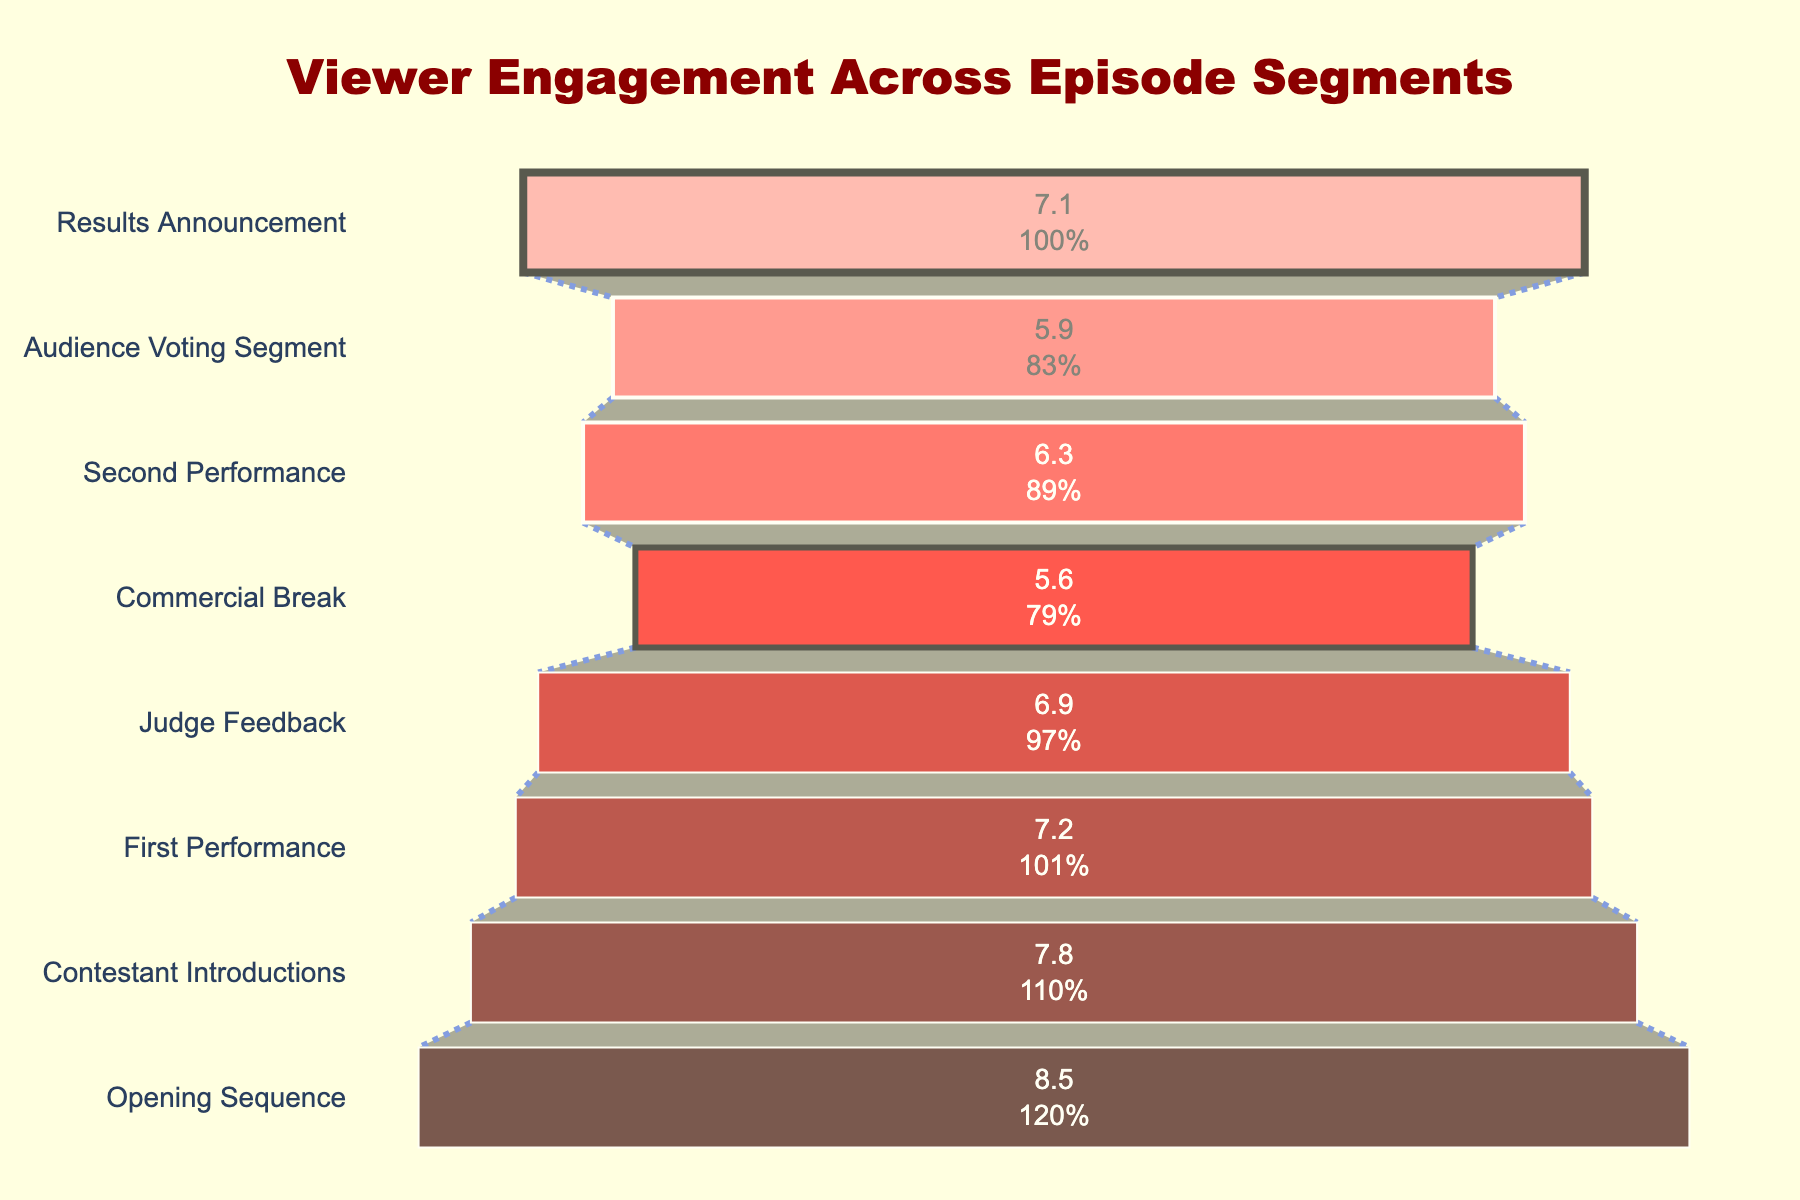What's the title of the figure? The title is displayed at the top center of the figure.
Answer: Viewer Engagement Across Episode Segments How many stages are represented in the funnel chart? We count the number of distinct segments (stages) shown along the funnel chart.
Answer: 8 What segment has the lowest viewer count? By examining the height of the bands or reading the text inside the bands, we identify the segment with the lowest value.
Answer: Commercial Break What is the total number of viewers from the Opening Sequence to the First Performance? We sum the viewers for the Opening Sequence, Contestant Introductions, and First Performance: 8.5 + 7.8 + 7.2 million viewers.
Answer: 23.5 million What percentage of the total initial viewership is retained by the Results Announcement segment? We compare the Results Announcement (7.1 million viewers) to the Opening Sequence (8.5 million viewers), calculating (7.1 / 8.5) * 100 to find the percentage retained.
Answer: 83.5% Which stage loses the most viewers compared to the previous stage? By calculating the difference between successive stages, we determine which has the largest decrease. The largest drop is from Judge Feedback (6.9) to Commercial Break (5.6).
Answer: Judge Feedback to Commercial Break How many fewer viewers were there during the Audience Voting Segment compared to the Opening Sequence? Subtract the viewers of the Audience Voting Segment (5.9 million) from the Opening Sequence (8.5 million). 8.5 - 5.9 = 2.6 million fewer viewers.
Answer: 2.6 million At which stage does the viewership increase compared to the immediately preceding stage? We look at the change in values between each consecutive stage and note where there is an increase. The viewership increases from Commercial Break (5.6 million) to Second Performance (6.3 million) and from Audience Voting Segment (5.9 million) to Results Announcement (7.1 million).
Answer: Second Performance, Results Announcement 